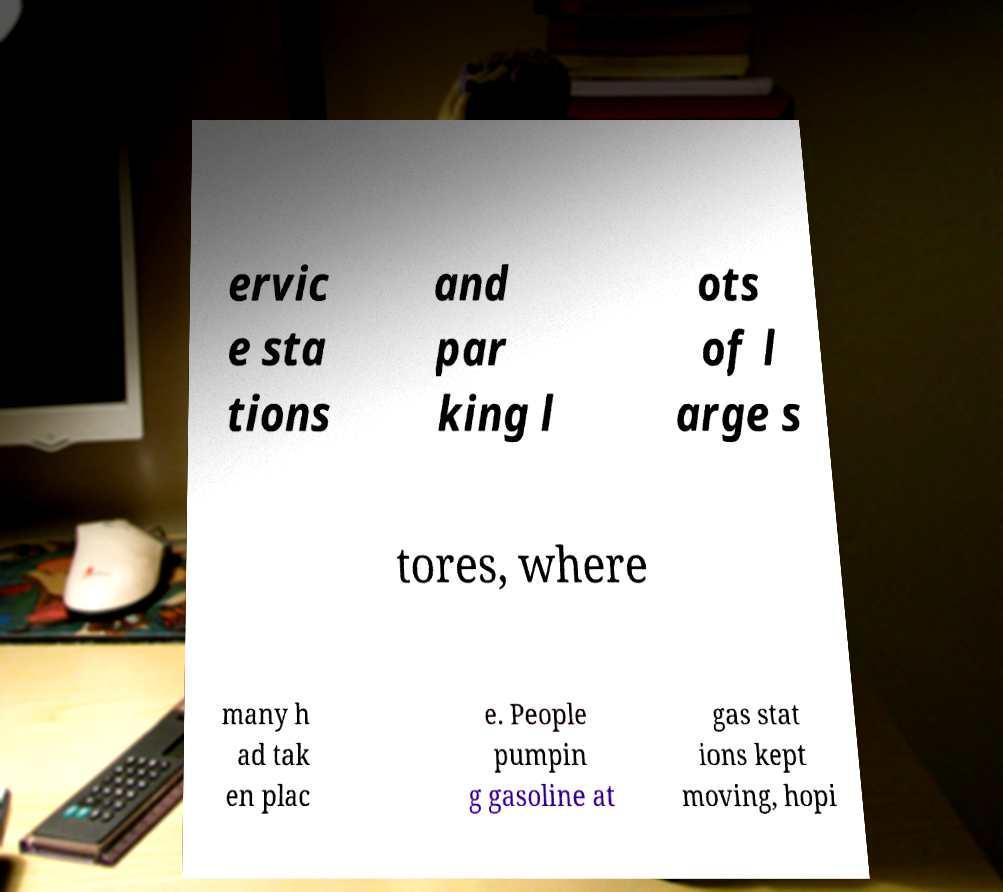Could you extract and type out the text from this image? ervic e sta tions and par king l ots of l arge s tores, where many h ad tak en plac e. People pumpin g gasoline at gas stat ions kept moving, hopi 